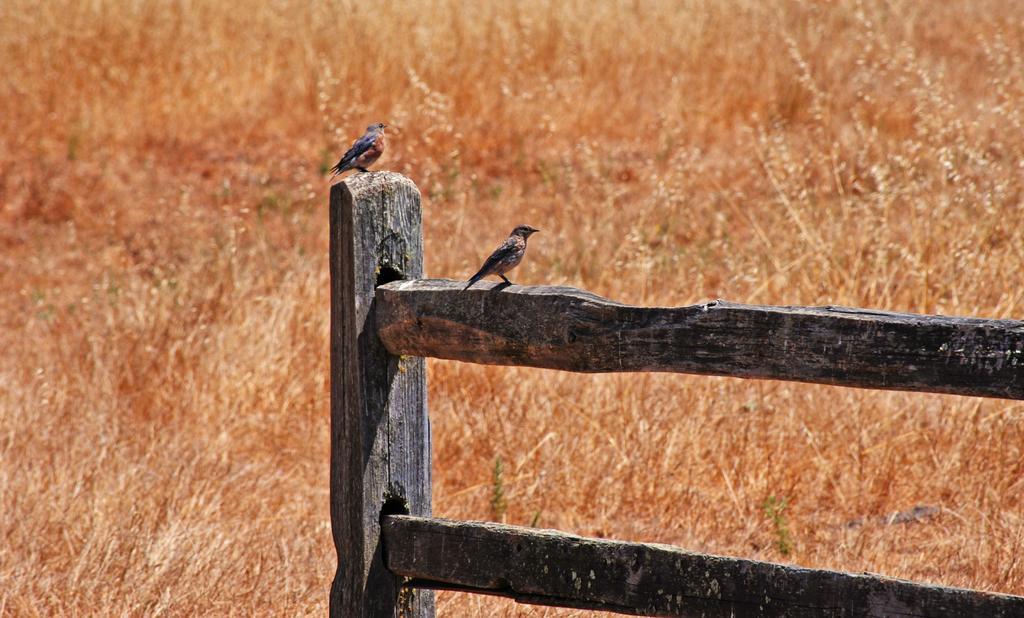Please provide a concise description of this image. In this image we can see there are two birds on the wooden fence and there is dry grass on the surface. 